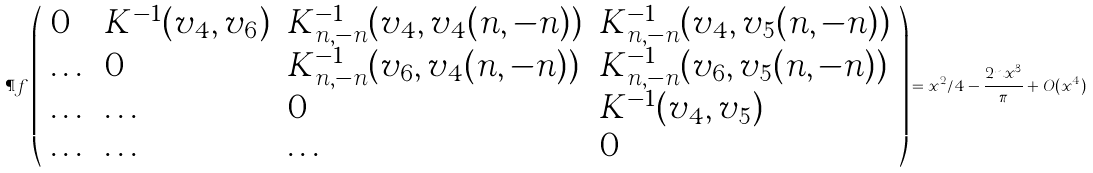<formula> <loc_0><loc_0><loc_500><loc_500>\P f \left ( \begin{array} { l l l l } 0 & K ^ { - 1 } ( v _ { 4 } , v _ { 6 } ) & K ^ { - 1 } _ { n , - n } ( v _ { 4 } , v _ { 4 } ( n , - n ) ) & K ^ { - 1 } _ { n , - n } ( v _ { 4 } , v _ { 5 } ( n , - n ) ) \\ \dots & 0 & K ^ { - 1 } _ { n , - n } ( v _ { 6 } , v _ { 4 } ( n , - n ) ) & K ^ { - 1 } _ { n , - n } ( v _ { 6 } , v _ { 5 } ( n , - n ) ) \\ \dots & \dots & 0 & K ^ { - 1 } ( v _ { 4 } , v _ { 5 } ) \\ \dots & \dots & \dots & 0 \end{array} \right ) = x ^ { 2 } / 4 - \frac { 2 n x ^ { 3 } } { \pi } + O ( x ^ { 4 } )</formula> 